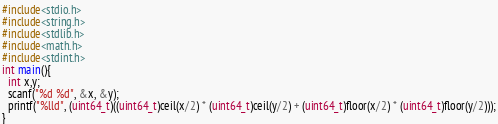<code> <loc_0><loc_0><loc_500><loc_500><_C_>#include<stdio.h>
#include<string.h>
#include<stdlib.h>
#include<math.h>
#include<stdint.h>
int main(){
  int x,y;
  scanf("%d %d", &x, &y);
  printf("%lld", (uint64_t)((uint64_t)ceil(x/2) * (uint64_t)ceil(y/2) + (uint64_t)floor(x/2) * (uint64_t)floor(y/2)));
}
</code> 